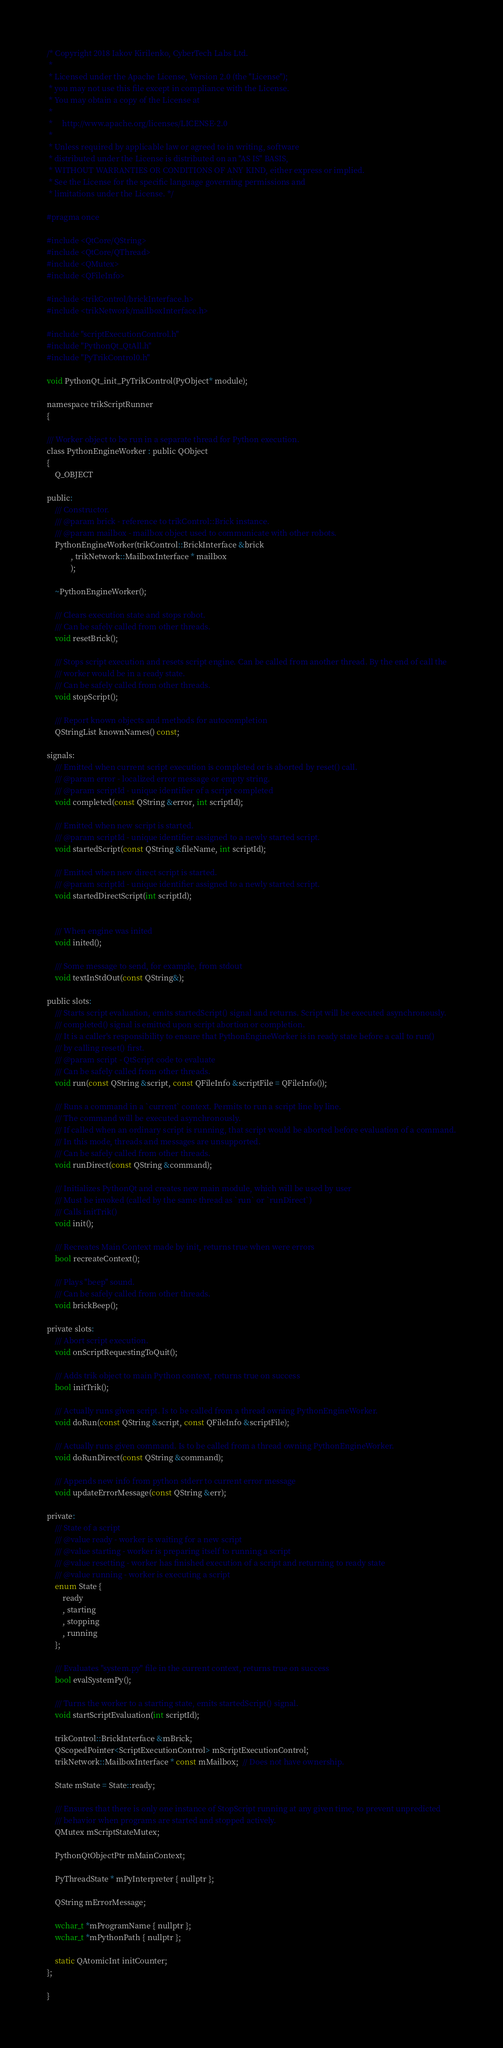Convert code to text. <code><loc_0><loc_0><loc_500><loc_500><_C_>/* Copyright 2018 Iakov Kirilenko, CyberTech Labs Ltd.
 *
 * Licensed under the Apache License, Version 2.0 (the "License");
 * you may not use this file except in compliance with the License.
 * You may obtain a copy of the License at
 *
 *     http://www.apache.org/licenses/LICENSE-2.0
 *
 * Unless required by applicable law or agreed to in writing, software
 * distributed under the License is distributed on an "AS IS" BASIS,
 * WITHOUT WARRANTIES OR CONDITIONS OF ANY KIND, either express or implied.
 * See the License for the specific language governing permissions and
 * limitations under the License. */

#pragma once

#include <QtCore/QString>
#include <QtCore/QThread>
#include <QMutex>
#include <QFileInfo>

#include <trikControl/brickInterface.h>
#include <trikNetwork/mailboxInterface.h>

#include "scriptExecutionControl.h"
#include "PythonQt_QtAll.h"
#include "PyTrikControl0.h"

void PythonQt_init_PyTrikControl(PyObject* module);

namespace trikScriptRunner
{

/// Worker object to be run in a separate thread for Python execution.
class PythonEngineWorker : public QObject
{
	Q_OBJECT

public:
	/// Constructor.
	/// @param brick - reference to trikControl::Brick instance.
	/// @param mailbox - mailbox object used to communicate with other robots.
	PythonEngineWorker(trikControl::BrickInterface &brick
			, trikNetwork::MailboxInterface * mailbox
			);

	~PythonEngineWorker();

	/// Clears execution state and stops robot.
	/// Can be safely called from other threads.
	void resetBrick();

	/// Stops script execution and resets script engine. Can be called from another thread. By the end of call the
	/// worker would be in a ready state.
	/// Can be safely called from other threads.
	void stopScript();

	/// Report known objects and methods for autocompletion
	QStringList knownNames() const;

signals:
	/// Emitted when current script execution is completed or is aborted by reset() call.
	/// @param error - localized error message or empty string.
	/// @param scriptId - unique identifier of a script completed
	void completed(const QString &error, int scriptId);

	/// Emitted when new script is started.
	/// @param scriptId - unique identifier assigned to a newly started script.
	void startedScript(const QString &fileName, int scriptId);

	/// Emitted when new direct script is started.
	/// @param scriptId - unique identifier assigned to a newly started script.
	void startedDirectScript(int scriptId);


	/// When engine was inited
	void inited();

	/// Some message to send, for example, from stdout
	void textInStdOut(const QString&);

public slots:
	/// Starts script evaluation, emits startedScript() signal and returns. Script will be executed asynchronously.
	/// completed() signal is emitted upon script abortion or completion.
	/// It is a caller's responsibility to ensure that PythonEngineWorker is in ready state before a call to run()
	/// by calling reset() first.
	/// @param script - QtScript code to evaluate
	/// Can be safely called from other threads.
	void run(const QString &script, const QFileInfo &scriptFile = QFileInfo());

	/// Runs a command in a `current` context. Permits to run a script line by line.
	/// The command will be executed asynchronously.
	/// If called when an ordinary script is running, that script would be aborted before evaluation of a command.
	/// In this mode, threads and messages are unsupported.
	/// Can be safely called from other threads.
	void runDirect(const QString &command);

	/// Initializes PythonQt and creates new main module, which will be used by user
	/// Must be invoked (called by the same thread as `run` or `runDirect`)
	/// Calls initTrik()
	void init();

	/// Recreates Main Context made by init, returns true when were errors
	bool recreateContext();

	/// Plays "beep" sound.
	/// Can be safely called from other threads.
	void brickBeep();

private slots:
	/// Abort script execution.
	void onScriptRequestingToQuit();

	/// Adds trik object to main Python context, returns true on success
	bool initTrik();

	/// Actually runs given script. Is to be called from a thread owning PythonEngineWorker.
	void doRun(const QString &script, const QFileInfo &scriptFile);

	/// Actually runs given command. Is to be called from a thread owning PythonEngineWorker.
	void doRunDirect(const QString &command);

	/// Appends new info from python stderr to current error message
	void updateErrorMessage(const QString &err);

private:
	/// State of a script
	/// @value ready - worker is waiting for a new script
	/// @value starting - worker is preparing itself to running a script
	/// @value resetting - worker has finished execution of a script and returning to ready state
	/// @value running - worker is executing a script
	enum State {
		ready
		, starting
		, stopping
		, running
	};

	/// Evaluates "system.py" file in the current context, returns true on success
	bool evalSystemPy();

	/// Turns the worker to a starting state, emits startedScript() signal.
	void startScriptEvaluation(int scriptId);

	trikControl::BrickInterface &mBrick;
	QScopedPointer<ScriptExecutionControl> mScriptExecutionControl;
	trikNetwork::MailboxInterface * const mMailbox;  // Does not have ownership.

	State mState = State::ready;

	/// Ensures that there is only one instance of StopScript running at any given time, to prevent unpredicted
	/// behavior when programs are started and stopped actively.
	QMutex mScriptStateMutex;

	PythonQtObjectPtr mMainContext;

	PyThreadState * mPyInterpreter { nullptr };

	QString mErrorMessage;

	wchar_t *mProgramName { nullptr };
	wchar_t *mPythonPath { nullptr };

	static QAtomicInt initCounter;
};

}
</code> 